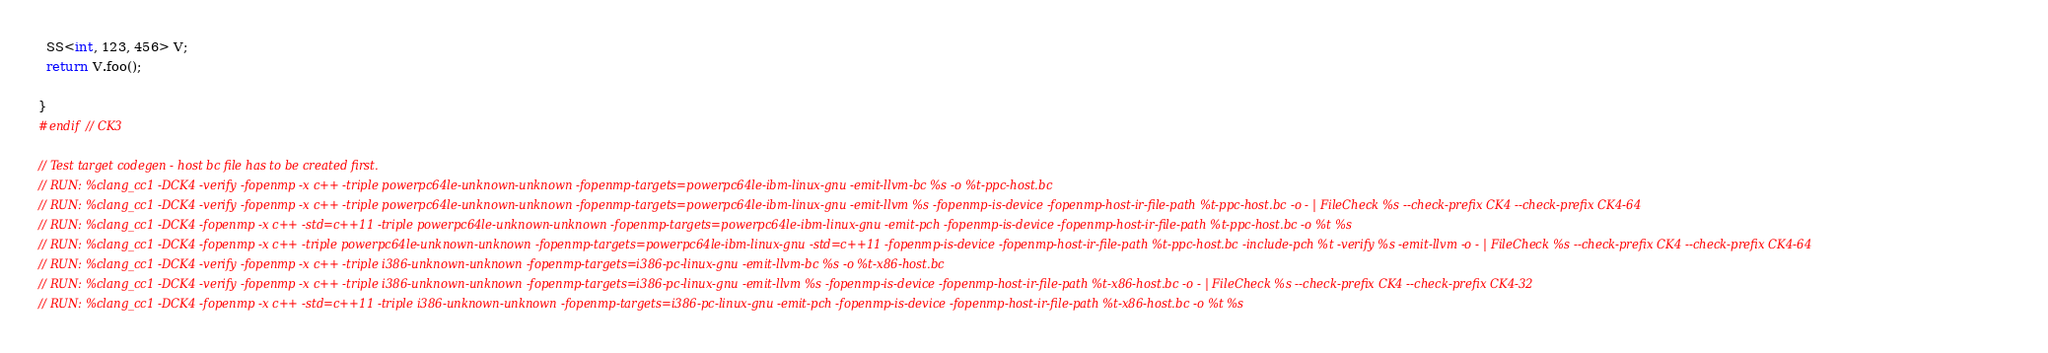<code> <loc_0><loc_0><loc_500><loc_500><_C++_>  SS<int, 123, 456> V;
  return V.foo();

}
#endif // CK3

// Test target codegen - host bc file has to be created first.
// RUN: %clang_cc1 -DCK4 -verify -fopenmp -x c++ -triple powerpc64le-unknown-unknown -fopenmp-targets=powerpc64le-ibm-linux-gnu -emit-llvm-bc %s -o %t-ppc-host.bc
// RUN: %clang_cc1 -DCK4 -verify -fopenmp -x c++ -triple powerpc64le-unknown-unknown -fopenmp-targets=powerpc64le-ibm-linux-gnu -emit-llvm %s -fopenmp-is-device -fopenmp-host-ir-file-path %t-ppc-host.bc -o - | FileCheck %s --check-prefix CK4 --check-prefix CK4-64
// RUN: %clang_cc1 -DCK4 -fopenmp -x c++ -std=c++11 -triple powerpc64le-unknown-unknown -fopenmp-targets=powerpc64le-ibm-linux-gnu -emit-pch -fopenmp-is-device -fopenmp-host-ir-file-path %t-ppc-host.bc -o %t %s
// RUN: %clang_cc1 -DCK4 -fopenmp -x c++ -triple powerpc64le-unknown-unknown -fopenmp-targets=powerpc64le-ibm-linux-gnu -std=c++11 -fopenmp-is-device -fopenmp-host-ir-file-path %t-ppc-host.bc -include-pch %t -verify %s -emit-llvm -o - | FileCheck %s --check-prefix CK4 --check-prefix CK4-64
// RUN: %clang_cc1 -DCK4 -verify -fopenmp -x c++ -triple i386-unknown-unknown -fopenmp-targets=i386-pc-linux-gnu -emit-llvm-bc %s -o %t-x86-host.bc
// RUN: %clang_cc1 -DCK4 -verify -fopenmp -x c++ -triple i386-unknown-unknown -fopenmp-targets=i386-pc-linux-gnu -emit-llvm %s -fopenmp-is-device -fopenmp-host-ir-file-path %t-x86-host.bc -o - | FileCheck %s --check-prefix CK4 --check-prefix CK4-32
// RUN: %clang_cc1 -DCK4 -fopenmp -x c++ -std=c++11 -triple i386-unknown-unknown -fopenmp-targets=i386-pc-linux-gnu -emit-pch -fopenmp-is-device -fopenmp-host-ir-file-path %t-x86-host.bc -o %t %s</code> 